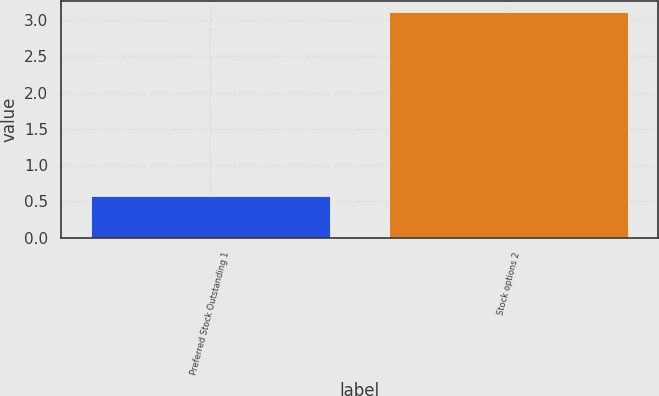Convert chart. <chart><loc_0><loc_0><loc_500><loc_500><bar_chart><fcel>Preferred Stock Outstanding 1<fcel>Stock options 2<nl><fcel>0.57<fcel>3.11<nl></chart> 